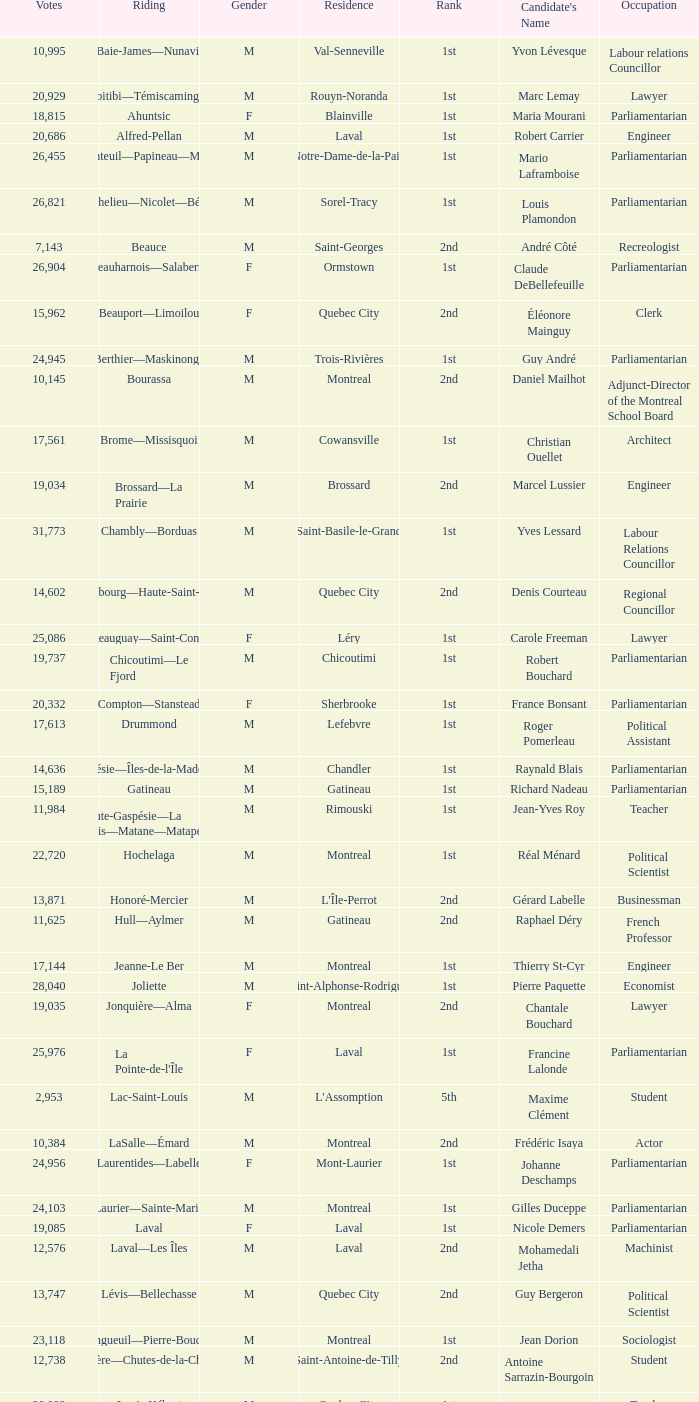What gender is Luc Desnoyers? M. 